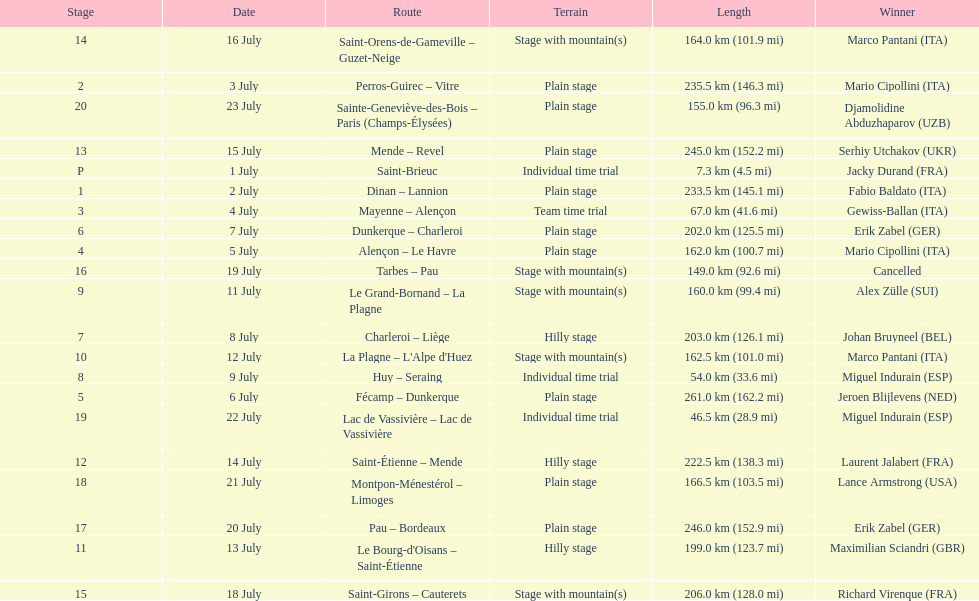How many consecutive km were raced on july 8th? 203.0 km (126.1 mi). 